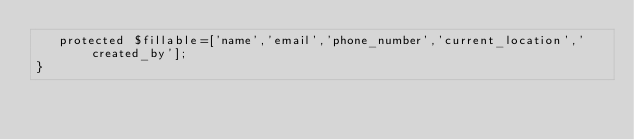Convert code to text. <code><loc_0><loc_0><loc_500><loc_500><_PHP_>   protected $fillable=['name','email','phone_number','current_location','created_by'];
}
</code> 